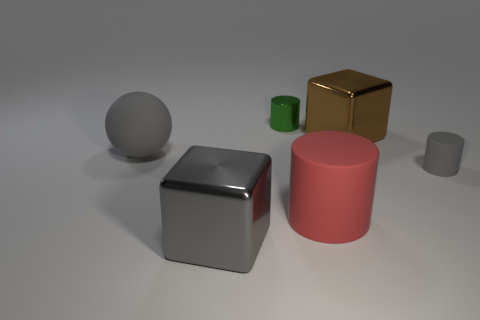Is the color of the small rubber cylinder the same as the metallic thing in front of the tiny gray cylinder?
Make the answer very short. Yes. What is the size of the metallic cube behind the large gray shiny thing?
Provide a succinct answer. Large. How many other things are there of the same shape as the green metal object?
Ensure brevity in your answer.  2. Do the big brown thing and the large gray shiny object have the same shape?
Provide a short and direct response. Yes. There is a big object that is to the left of the large rubber cylinder and on the right side of the gray matte sphere; what color is it?
Offer a terse response. Gray. What size is the metal cube that is the same color as the small matte object?
Your answer should be very brief. Large. What number of big objects are matte balls or red rubber objects?
Provide a short and direct response. 2. Is there anything else of the same color as the rubber sphere?
Make the answer very short. Yes. There is a large gray thing that is in front of the thing to the left of the big gray object that is right of the matte ball; what is its material?
Ensure brevity in your answer.  Metal. How many metallic things are gray things or small green things?
Give a very brief answer. 2. 